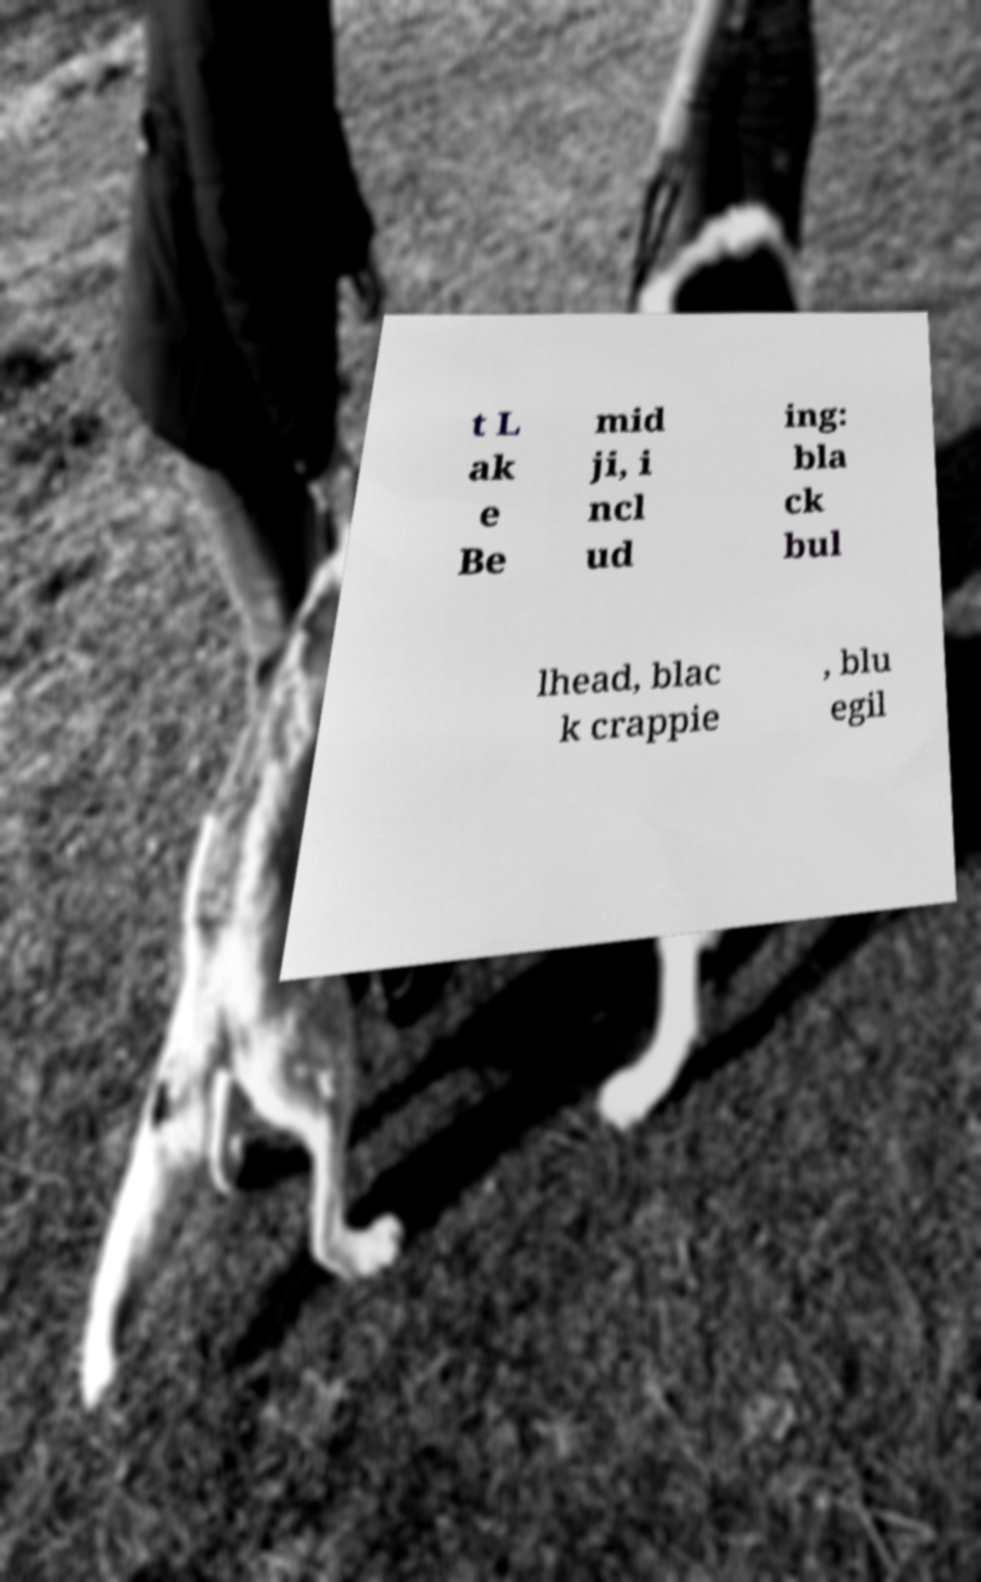Could you extract and type out the text from this image? t L ak e Be mid ji, i ncl ud ing: bla ck bul lhead, blac k crappie , blu egil 